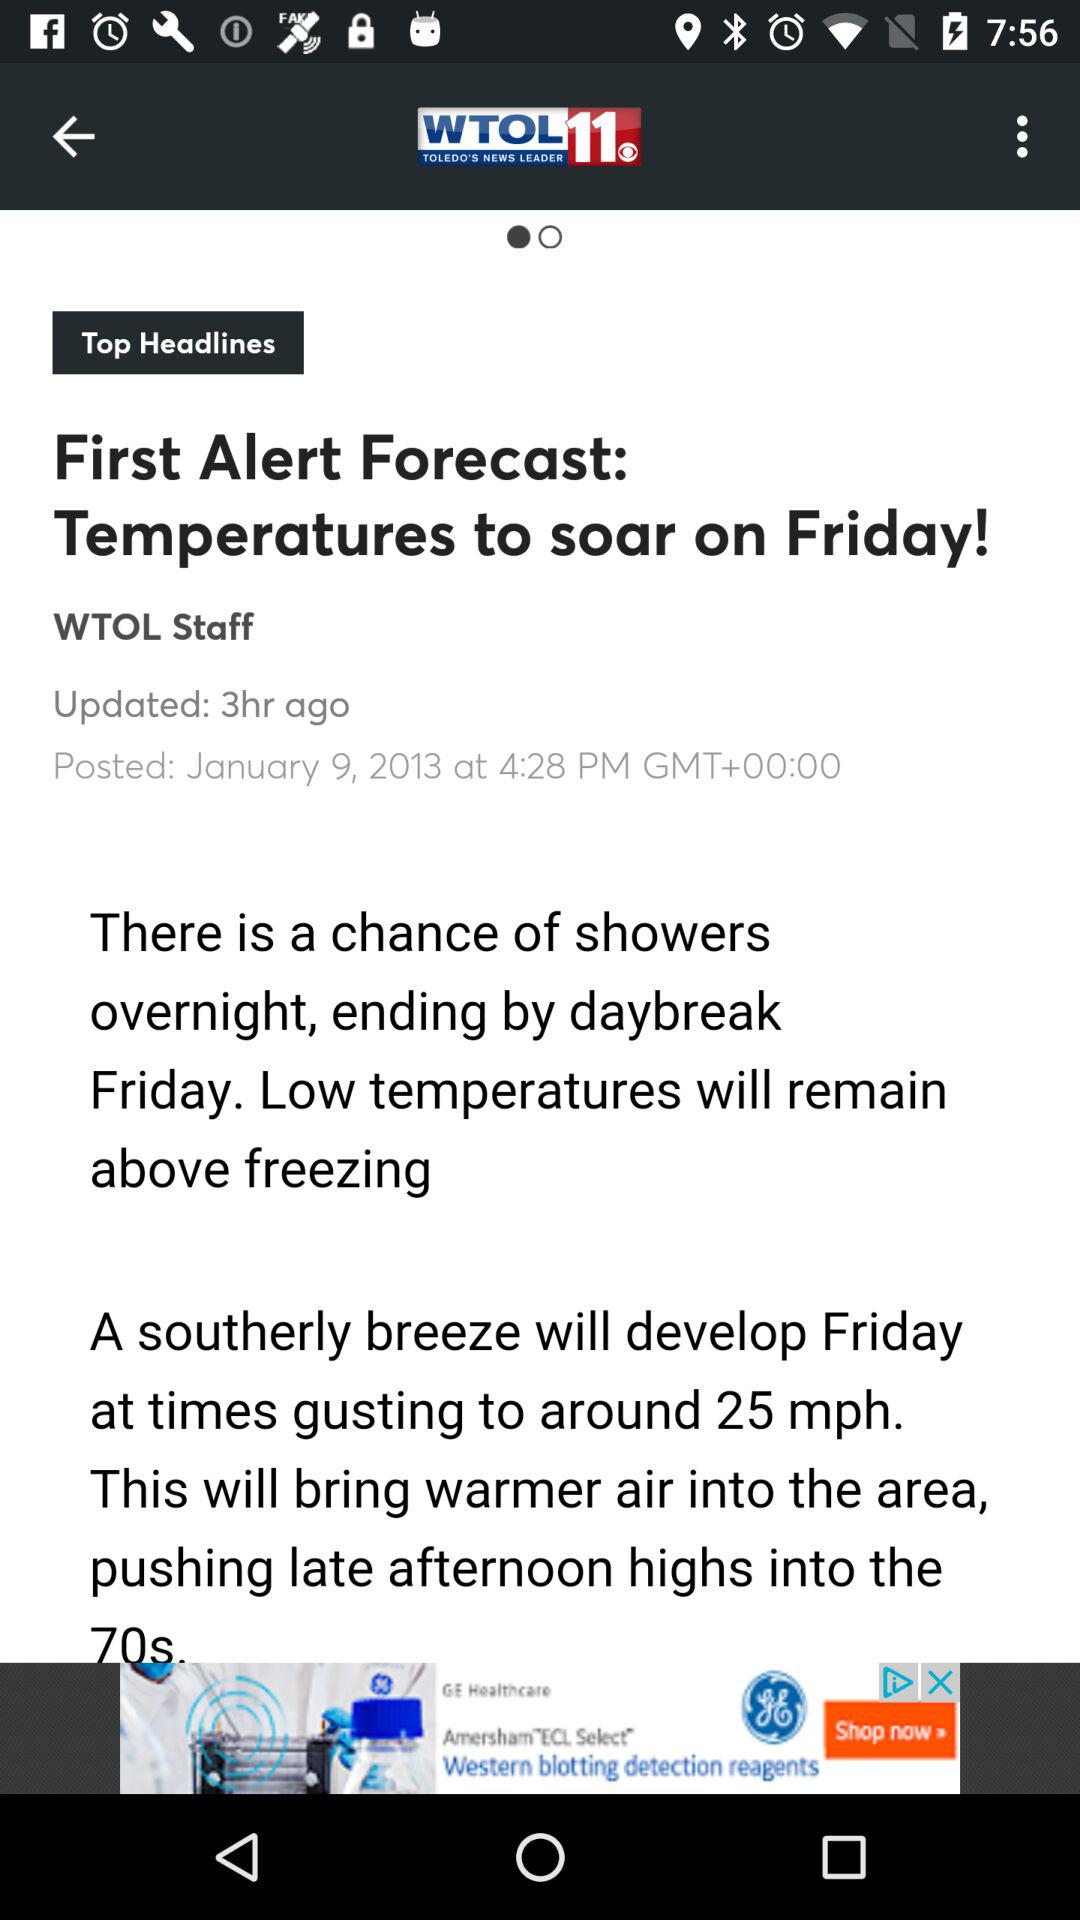When was the article updated? The article was updated 3 hours ago. 